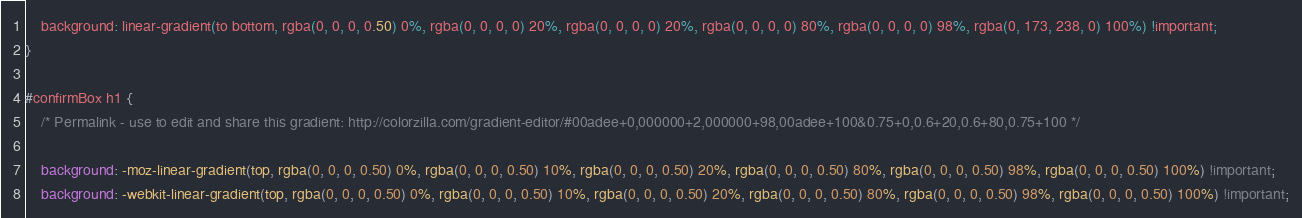<code> <loc_0><loc_0><loc_500><loc_500><_CSS_>    background: linear-gradient(to bottom, rgba(0, 0, 0, 0.50) 0%, rgba(0, 0, 0, 0) 20%, rgba(0, 0, 0, 0) 20%, rgba(0, 0, 0, 0) 80%, rgba(0, 0, 0, 0) 98%, rgba(0, 173, 238, 0) 100%) !important;
}

#confirmBox h1 {
    /* Permalink - use to edit and share this gradient: http://colorzilla.com/gradient-editor/#00adee+0,000000+2,000000+98,00adee+100&0.75+0,0.6+20,0.6+80,0.75+100 */
    
    background: -moz-linear-gradient(top, rgba(0, 0, 0, 0.50) 0%, rgba(0, 0, 0, 0.50) 10%, rgba(0, 0, 0, 0.50) 20%, rgba(0, 0, 0, 0.50) 80%, rgba(0, 0, 0, 0.50) 98%, rgba(0, 0, 0, 0.50) 100%) !important;
    background: -webkit-linear-gradient(top, rgba(0, 0, 0, 0.50) 0%, rgba(0, 0, 0, 0.50) 10%, rgba(0, 0, 0, 0.50) 20%, rgba(0, 0, 0, 0.50) 80%, rgba(0, 0, 0, 0.50) 98%, rgba(0, 0, 0, 0.50) 100%) !important;</code> 